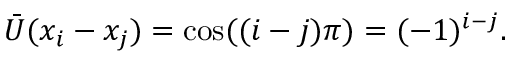<formula> <loc_0><loc_0><loc_500><loc_500>\bar { U } ( x _ { i } - x _ { j } ) = \cos ( ( i - j ) \pi ) = ( - 1 ) ^ { i - j } .</formula> 